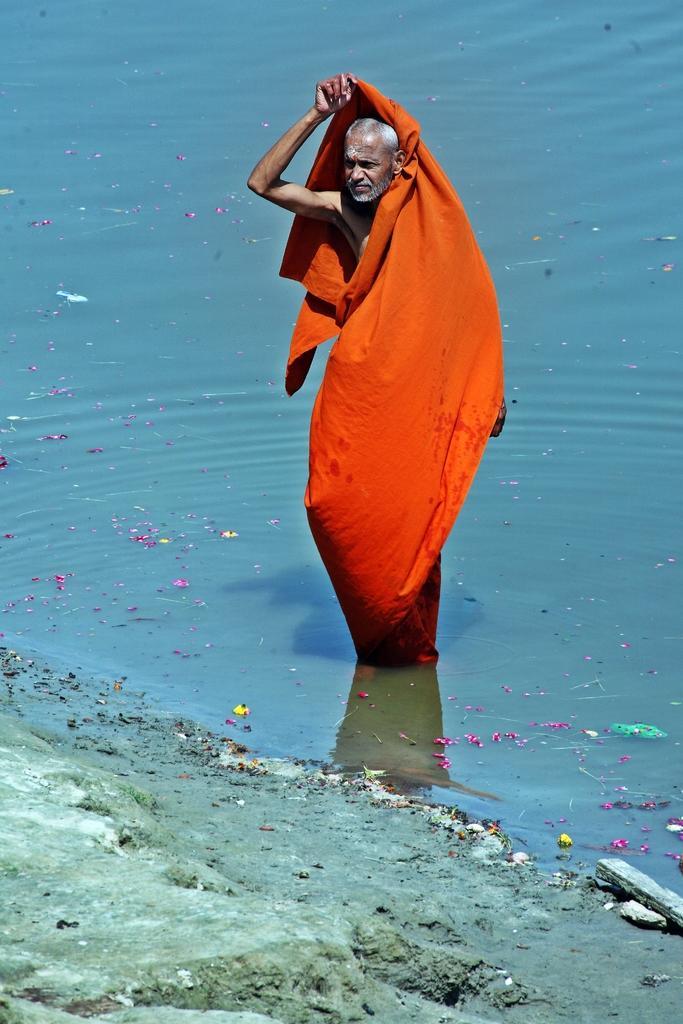Please provide a concise description of this image. In this image I can see the person with an orange color cloth. I can see the person standing in the water. In-front of the person I can see the rock. 